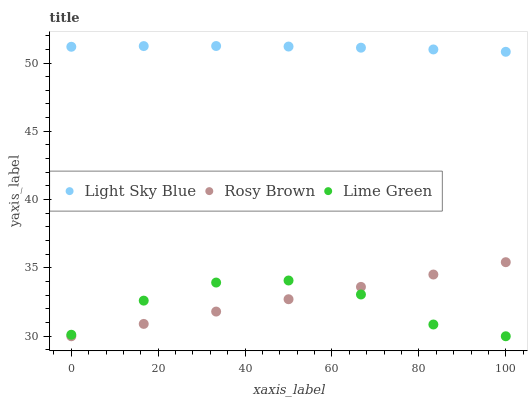Does Lime Green have the minimum area under the curve?
Answer yes or no. Yes. Does Light Sky Blue have the maximum area under the curve?
Answer yes or no. Yes. Does Light Sky Blue have the minimum area under the curve?
Answer yes or no. No. Does Lime Green have the maximum area under the curve?
Answer yes or no. No. Is Rosy Brown the smoothest?
Answer yes or no. Yes. Is Lime Green the roughest?
Answer yes or no. Yes. Is Light Sky Blue the smoothest?
Answer yes or no. No. Is Light Sky Blue the roughest?
Answer yes or no. No. Does Rosy Brown have the lowest value?
Answer yes or no. Yes. Does Light Sky Blue have the lowest value?
Answer yes or no. No. Does Light Sky Blue have the highest value?
Answer yes or no. Yes. Does Lime Green have the highest value?
Answer yes or no. No. Is Rosy Brown less than Light Sky Blue?
Answer yes or no. Yes. Is Light Sky Blue greater than Rosy Brown?
Answer yes or no. Yes. Does Rosy Brown intersect Lime Green?
Answer yes or no. Yes. Is Rosy Brown less than Lime Green?
Answer yes or no. No. Is Rosy Brown greater than Lime Green?
Answer yes or no. No. Does Rosy Brown intersect Light Sky Blue?
Answer yes or no. No. 